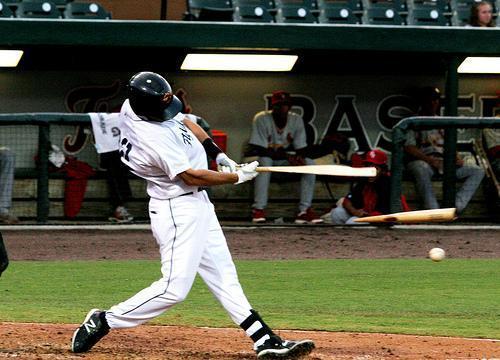How many players shown are on offense?
Give a very brief answer. 1. How many football players are running into the end zone?
Give a very brief answer. 0. How many players have a helmet on?
Give a very brief answer. 1. 